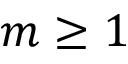Convert formula to latex. <formula><loc_0><loc_0><loc_500><loc_500>m \geq 1</formula> 